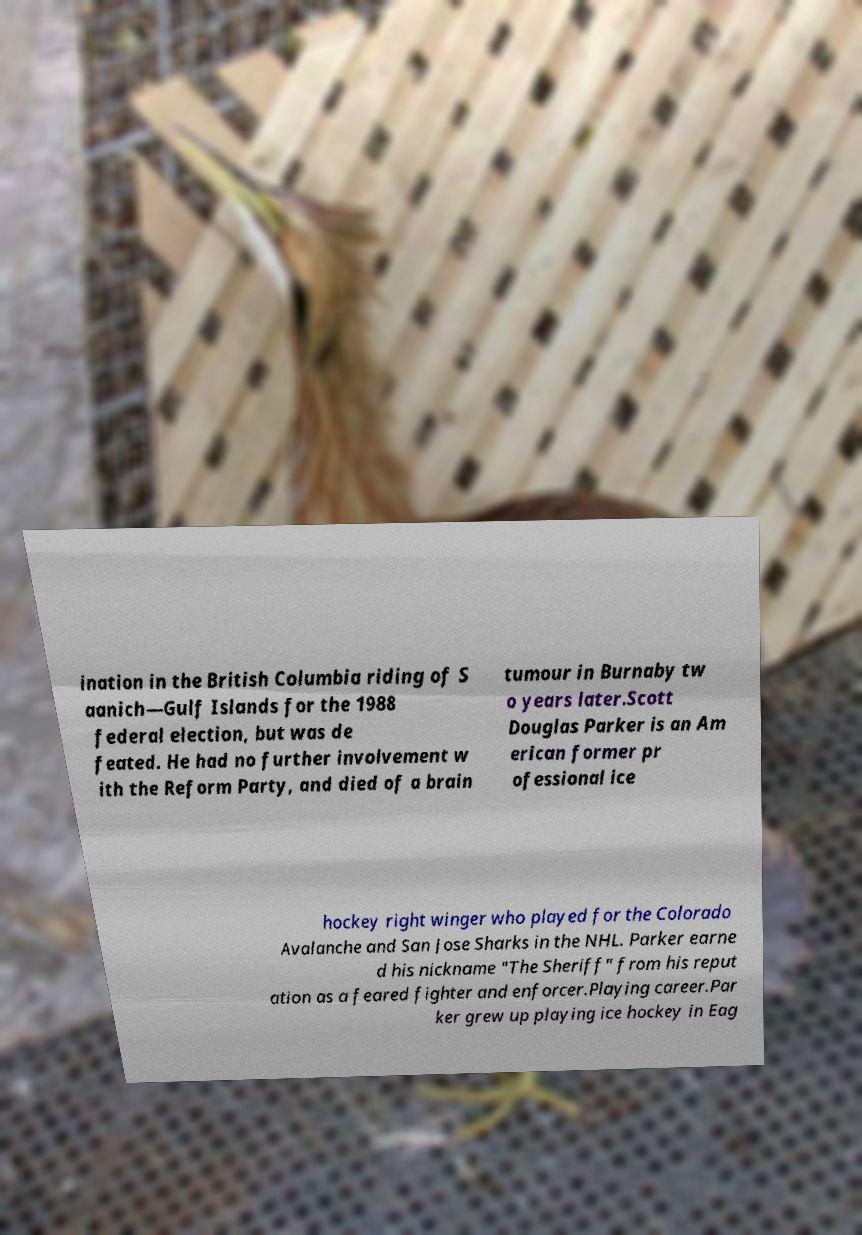What messages or text are displayed in this image? I need them in a readable, typed format. ination in the British Columbia riding of S aanich—Gulf Islands for the 1988 federal election, but was de feated. He had no further involvement w ith the Reform Party, and died of a brain tumour in Burnaby tw o years later.Scott Douglas Parker is an Am erican former pr ofessional ice hockey right winger who played for the Colorado Avalanche and San Jose Sharks in the NHL. Parker earne d his nickname "The Sheriff" from his reput ation as a feared fighter and enforcer.Playing career.Par ker grew up playing ice hockey in Eag 